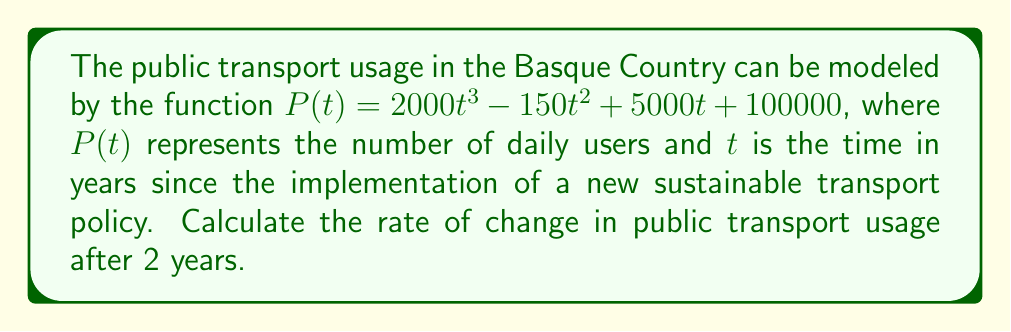What is the answer to this math problem? To find the rate of change in public transport usage after 2 years, we need to calculate the derivative of $P(t)$ and evaluate it at $t=2$. Here's the step-by-step process:

1. Given function: $P(t) = 2000t^3 - 150t^2 + 5000t + 100000$

2. Calculate the derivative $P'(t)$:
   $P'(t) = \frac{d}{dt}(2000t^3 - 150t^2 + 5000t + 100000)$
   $P'(t) = 6000t^2 - 300t + 5000$

3. Evaluate $P'(t)$ at $t=2$:
   $P'(2) = 6000(2)^2 - 300(2) + 5000$
   $P'(2) = 6000(4) - 600 + 5000$
   $P'(2) = 24000 - 600 + 5000$
   $P'(2) = 28400$

The rate of change after 2 years is 28,400 users per year.
Answer: 28,400 users/year 